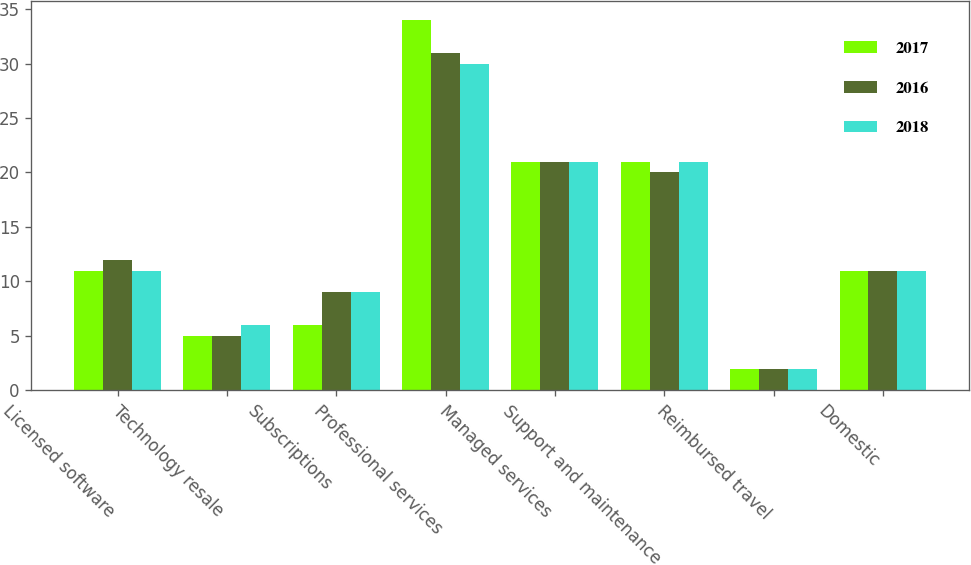Convert chart to OTSL. <chart><loc_0><loc_0><loc_500><loc_500><stacked_bar_chart><ecel><fcel>Licensed software<fcel>Technology resale<fcel>Subscriptions<fcel>Professional services<fcel>Managed services<fcel>Support and maintenance<fcel>Reimbursed travel<fcel>Domestic<nl><fcel>2017<fcel>11<fcel>5<fcel>6<fcel>34<fcel>21<fcel>21<fcel>2<fcel>11<nl><fcel>2016<fcel>12<fcel>5<fcel>9<fcel>31<fcel>21<fcel>20<fcel>2<fcel>11<nl><fcel>2018<fcel>11<fcel>6<fcel>9<fcel>30<fcel>21<fcel>21<fcel>2<fcel>11<nl></chart> 